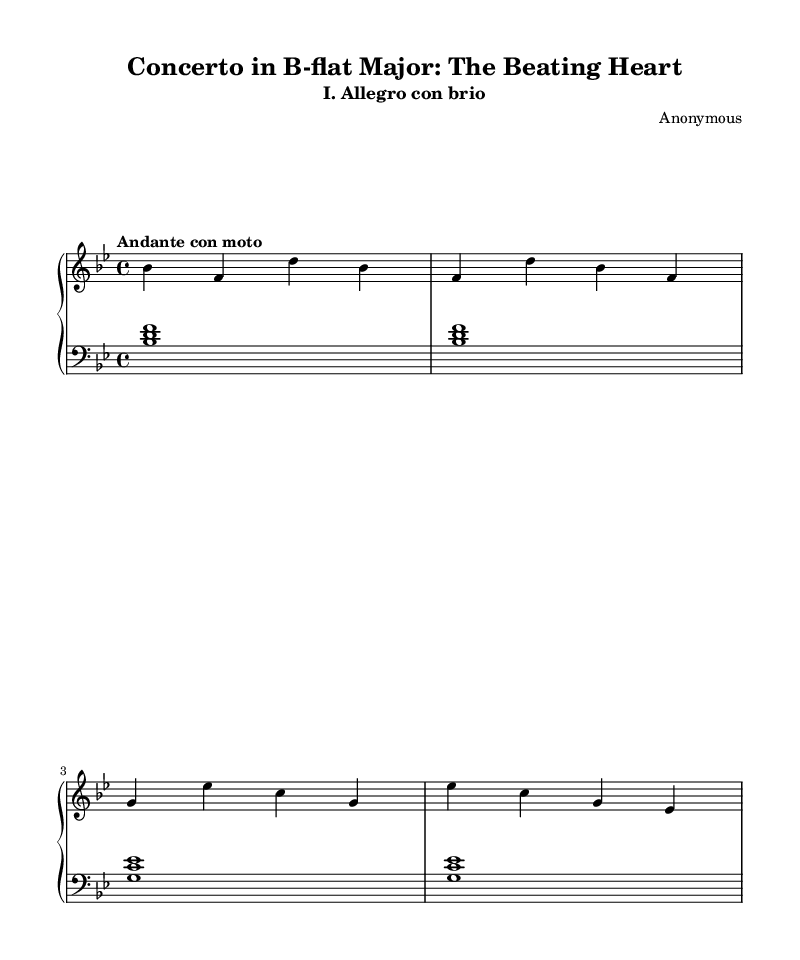What is the key signature of this music? The key signature is indicated at the beginning of the staff, showing two flats (B-flat and E-flat). This confirms that the key is B-flat major.
Answer: B-flat major What is the time signature of this piece? The time signature appears at the beginning of the staff and is represented by the fraction 4/4, indicating that there are four beats per measure.
Answer: 4/4 What is the tempo marking for this movement? The tempo marking is specified above the staff as "Andante con moto," which provides guidance on the speed of the piece.
Answer: Andante con moto How many measures are shown in the provided section? By counting the individual groupings of notes and rests, we can observe that there are four complete measures in the provided excerpt.
Answer: 4 What is the function of the left hand in this piece? The left hand plays chords and outlines the harmony, specifically playing root notes and their corresponding intervals, which supports the melody played by the right hand.
Answer: Harmony Identify the thematic element represented in the title "The Beating Heart." The title suggests a metaphorical connection with the consistent and steady pace of the music, reminiscent of a heart's rhythmic beating, which aligns with the Andante tempo marking.
Answer: Rhythm What is the interval between the first two notes of the right hand? The first note is B-flat (bes) and the second note is F. The interval between B-flat and F is a perfect fourth.
Answer: Perfect fourth 